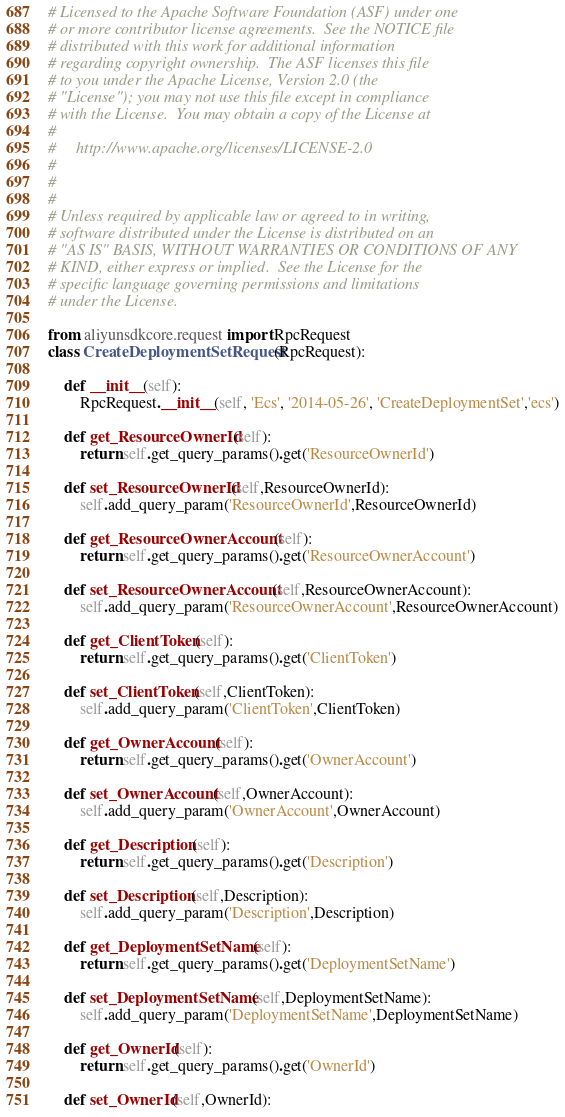<code> <loc_0><loc_0><loc_500><loc_500><_Python_># Licensed to the Apache Software Foundation (ASF) under one
# or more contributor license agreements.  See the NOTICE file
# distributed with this work for additional information
# regarding copyright ownership.  The ASF licenses this file
# to you under the Apache License, Version 2.0 (the
# "License"); you may not use this file except in compliance
# with the License.  You may obtain a copy of the License at
#
#     http://www.apache.org/licenses/LICENSE-2.0
#
#
#
# Unless required by applicable law or agreed to in writing,
# software distributed under the License is distributed on an
# "AS IS" BASIS, WITHOUT WARRANTIES OR CONDITIONS OF ANY
# KIND, either express or implied.  See the License for the
# specific language governing permissions and limitations
# under the License.

from aliyunsdkcore.request import RpcRequest
class CreateDeploymentSetRequest(RpcRequest):

	def __init__(self):
		RpcRequest.__init__(self, 'Ecs', '2014-05-26', 'CreateDeploymentSet','ecs')

	def get_ResourceOwnerId(self):
		return self.get_query_params().get('ResourceOwnerId')

	def set_ResourceOwnerId(self,ResourceOwnerId):
		self.add_query_param('ResourceOwnerId',ResourceOwnerId)

	def get_ResourceOwnerAccount(self):
		return self.get_query_params().get('ResourceOwnerAccount')

	def set_ResourceOwnerAccount(self,ResourceOwnerAccount):
		self.add_query_param('ResourceOwnerAccount',ResourceOwnerAccount)

	def get_ClientToken(self):
		return self.get_query_params().get('ClientToken')

	def set_ClientToken(self,ClientToken):
		self.add_query_param('ClientToken',ClientToken)

	def get_OwnerAccount(self):
		return self.get_query_params().get('OwnerAccount')

	def set_OwnerAccount(self,OwnerAccount):
		self.add_query_param('OwnerAccount',OwnerAccount)

	def get_Description(self):
		return self.get_query_params().get('Description')

	def set_Description(self,Description):
		self.add_query_param('Description',Description)

	def get_DeploymentSetName(self):
		return self.get_query_params().get('DeploymentSetName')

	def set_DeploymentSetName(self,DeploymentSetName):
		self.add_query_param('DeploymentSetName',DeploymentSetName)

	def get_OwnerId(self):
		return self.get_query_params().get('OwnerId')

	def set_OwnerId(self,OwnerId):</code> 